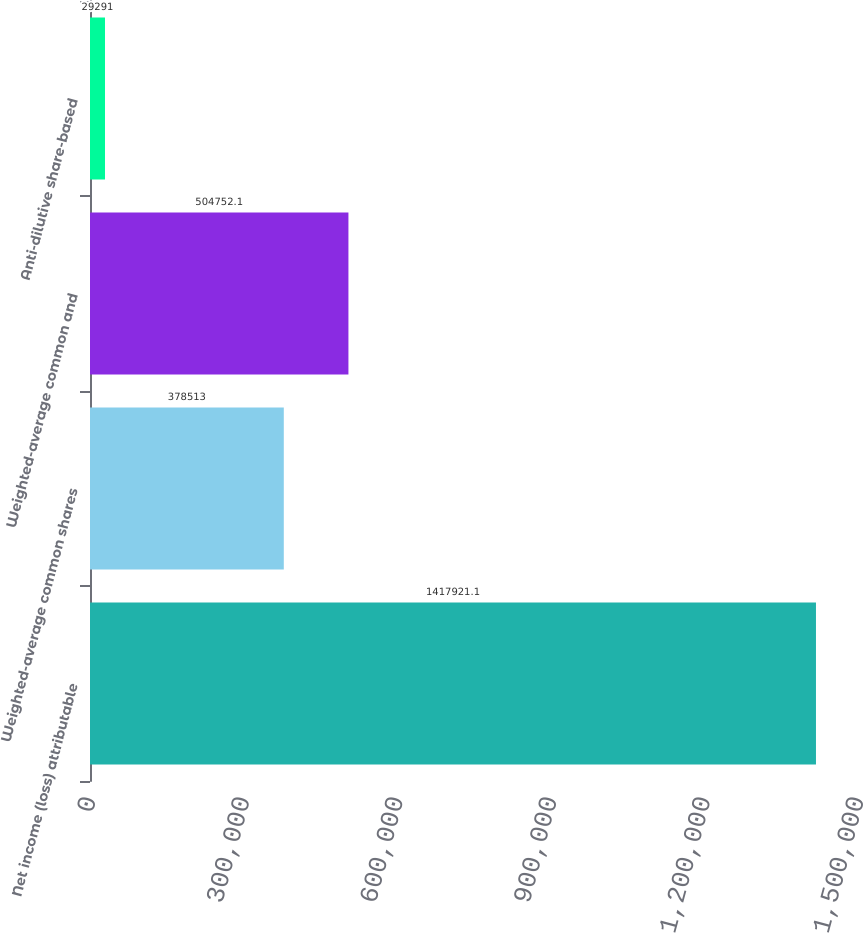Convert chart to OTSL. <chart><loc_0><loc_0><loc_500><loc_500><bar_chart><fcel>Net income (loss) attributable<fcel>Weighted-average common shares<fcel>Weighted-average common and<fcel>Anti-dilutive share-based<nl><fcel>1.41792e+06<fcel>378513<fcel>504752<fcel>29291<nl></chart> 